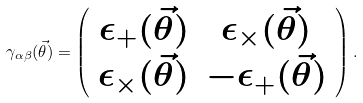Convert formula to latex. <formula><loc_0><loc_0><loc_500><loc_500>\gamma _ { \alpha \beta } ( \vec { \theta } ) = \left ( \begin{array} { c c } \epsilon _ { + } ( \vec { \theta } ) & \epsilon _ { \times } ( \vec { \theta } ) \\ \epsilon _ { \times } ( \vec { \theta } ) & - \epsilon _ { + } ( \vec { \theta } ) \\ \end{array} \right ) .</formula> 